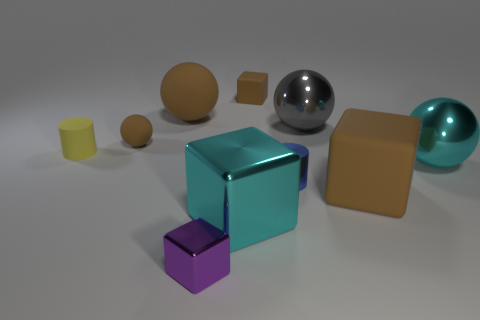Is the color of the small matte ball the same as the large matte block?
Your answer should be compact. Yes. What material is the big thing that is on the left side of the blue thing and right of the large brown matte sphere?
Make the answer very short. Metal. There is a large matte thing that is on the left side of the purple metal block; is there a large brown matte thing that is on the right side of it?
Make the answer very short. Yes. What number of objects are either big blocks or purple cubes?
Offer a terse response. 3. What shape is the object that is to the left of the big brown matte cube and to the right of the small metal cylinder?
Provide a succinct answer. Sphere. Is the material of the big sphere that is to the left of the tiny metal block the same as the small yellow object?
Offer a terse response. Yes. How many things are large cyan things or gray metallic things that are behind the metallic cylinder?
Offer a very short reply. 3. There is a small ball that is the same material as the tiny yellow cylinder; what color is it?
Ensure brevity in your answer.  Brown. How many tiny purple blocks are the same material as the cyan ball?
Keep it short and to the point. 1. What number of purple metal balls are there?
Your response must be concise. 0. 